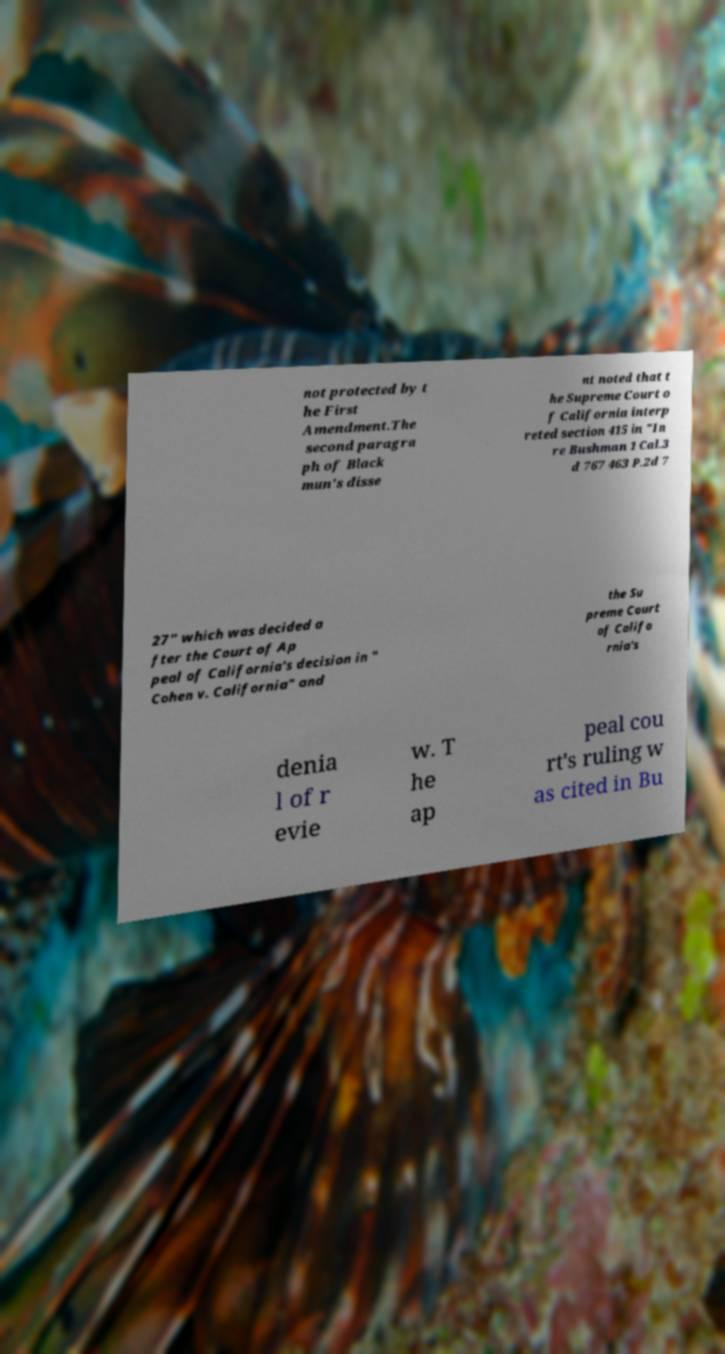For documentation purposes, I need the text within this image transcribed. Could you provide that? not protected by t he First Amendment.The second paragra ph of Black mun's disse nt noted that t he Supreme Court o f California interp reted section 415 in "In re Bushman 1 Cal.3 d 767 463 P.2d 7 27" which was decided a fter the Court of Ap peal of California's decision in " Cohen v. California" and the Su preme Court of Califo rnia's denia l of r evie w. T he ap peal cou rt's ruling w as cited in Bu 